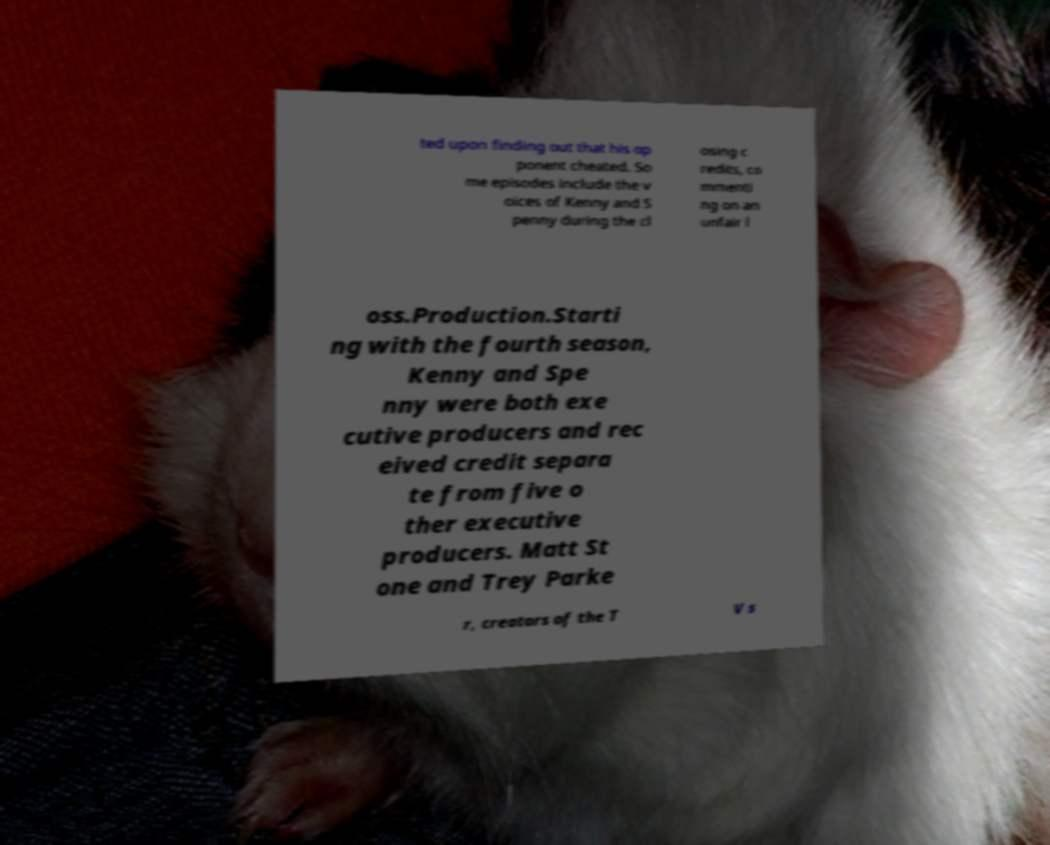There's text embedded in this image that I need extracted. Can you transcribe it verbatim? ted upon finding out that his op ponent cheated. So me episodes include the v oices of Kenny and S penny during the cl osing c redits, co mmenti ng on an unfair l oss.Production.Starti ng with the fourth season, Kenny and Spe nny were both exe cutive producers and rec eived credit separa te from five o ther executive producers. Matt St one and Trey Parke r, creators of the T V s 